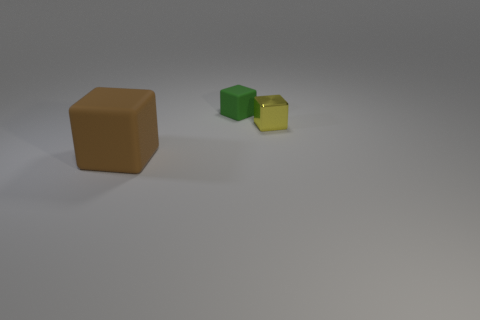Add 3 large brown matte cubes. How many objects exist? 6 Add 1 green things. How many green things are left? 2 Add 3 small yellow cubes. How many small yellow cubes exist? 4 Subtract 0 red cylinders. How many objects are left? 3 Subtract all green matte cubes. Subtract all small yellow matte cubes. How many objects are left? 2 